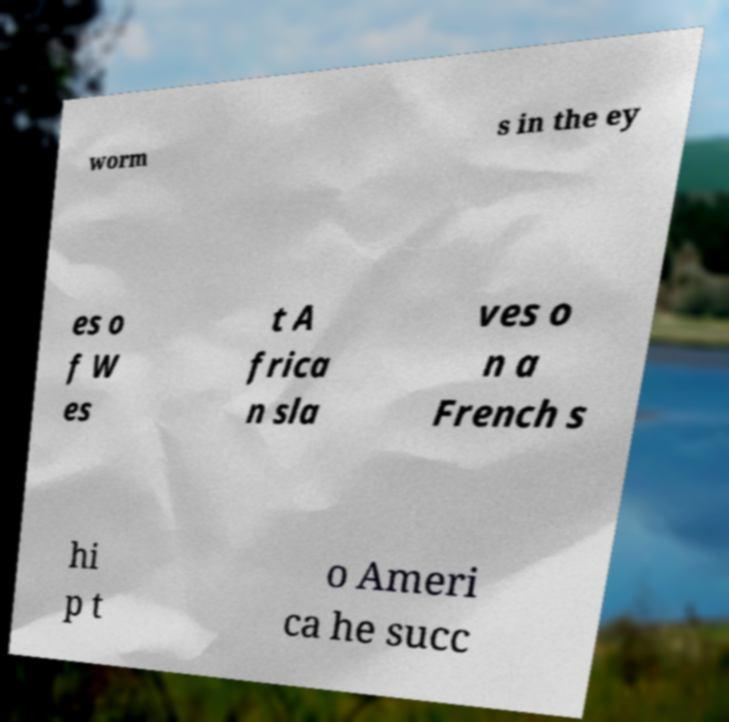Could you extract and type out the text from this image? worm s in the ey es o f W es t A frica n sla ves o n a French s hi p t o Ameri ca he succ 